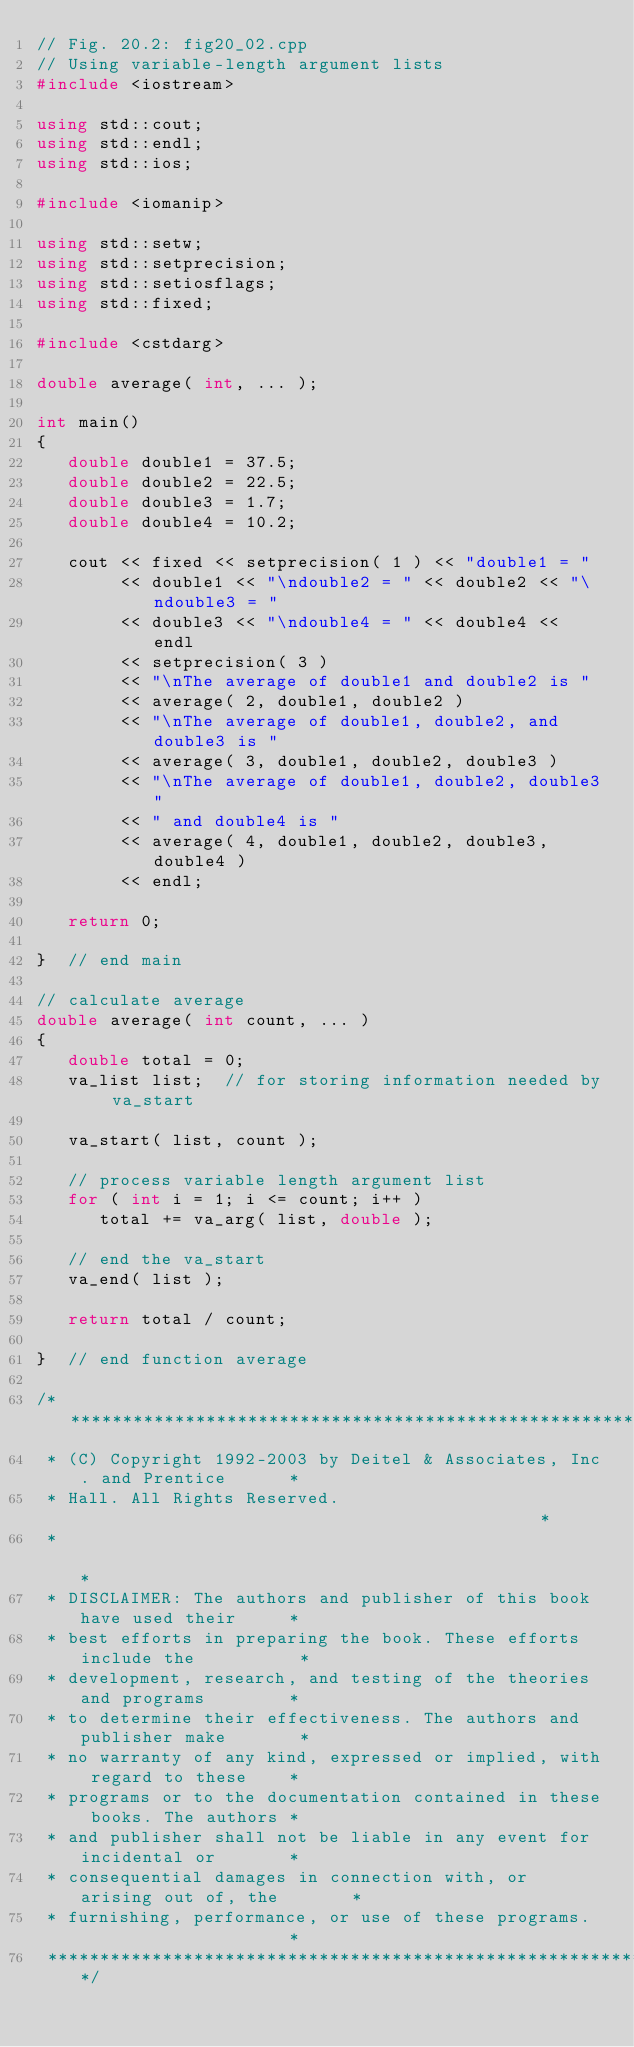Convert code to text. <code><loc_0><loc_0><loc_500><loc_500><_C++_>// Fig. 20.2: fig20_02.cpp
// Using variable-length argument lists
#include <iostream>

using std::cout;
using std::endl;
using std::ios;

#include <iomanip>

using std::setw;
using std::setprecision;
using std::setiosflags;
using std::fixed;

#include <cstdarg>

double average( int, ... );

int main()
{
   double double1 = 37.5;
   double double2 = 22.5;
   double double3 = 1.7;
   double double4 = 10.2;

   cout << fixed << setprecision( 1 ) << "double1 = " 
        << double1 << "\ndouble2 = " << double2 << "\ndouble3 = "
        << double3 << "\ndouble4 = " << double4 << endl
        << setprecision( 3 ) 
        << "\nThe average of double1 and double2 is " 
        << average( 2, double1, double2 )
        << "\nThe average of double1, double2, and double3 is " 
        << average( 3, double1, double2, double3 ) 
        << "\nThe average of double1, double2, double3"
        << " and double4 is " 
        << average( 4, double1, double2, double3, double4 ) 
        << endl;

   return 0;

}  // end main

// calculate average
double average( int count, ... )
{
   double total = 0;
   va_list list;  // for storing information needed by va_start
 
   va_start( list, count );

   // process variable length argument list
   for ( int i = 1; i <= count; i++ )
      total += va_arg( list, double );

   // end the va_start
   va_end( list );

   return total / count;

}  // end function average

/**************************************************************************
 * (C) Copyright 1992-2003 by Deitel & Associates, Inc. and Prentice      *
 * Hall. All Rights Reserved.                                             *
 *                                                                        *
 * DISCLAIMER: The authors and publisher of this book have used their     *
 * best efforts in preparing the book. These efforts include the          *
 * development, research, and testing of the theories and programs        *
 * to determine their effectiveness. The authors and publisher make       *
 * no warranty of any kind, expressed or implied, with regard to these    *
 * programs or to the documentation contained in these books. The authors *
 * and publisher shall not be liable in any event for incidental or       *
 * consequential damages in connection with, or arising out of, the       *
 * furnishing, performance, or use of these programs.                     *
 *************************************************************************/
</code> 